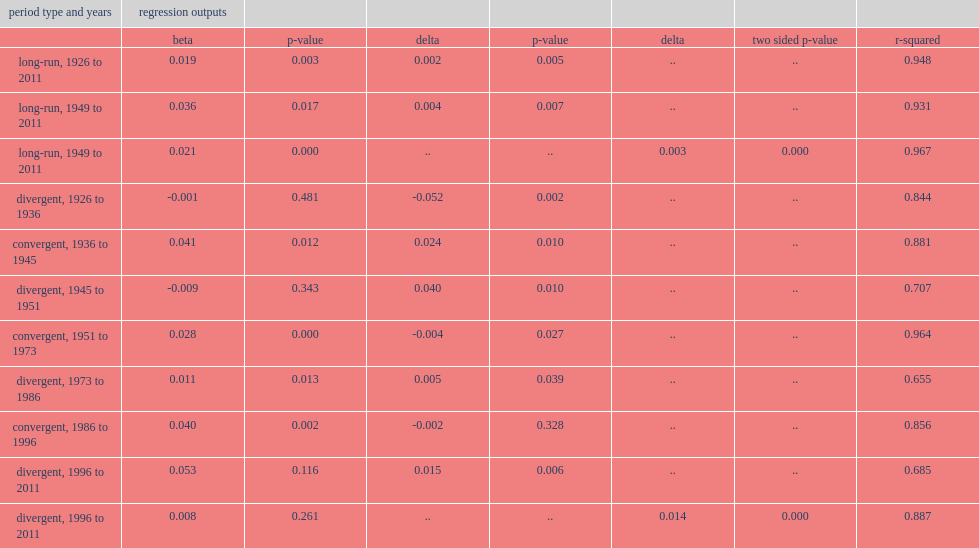For the three periods of convergence, the conditional convergence rate is slower than the unconditional rate, what was the percentage of convergent for 1936 to 1945? 0.041. For the three periods of convergence, the conditional convergence rate is slower than the unconditional rate, what was the percentage of convergent for 1951 to 1973? 0.028. For the three periods of convergence, the conditional convergence rate is slower than the unconditional rate, what was the percentage of convergent for 1951 to 1973? 0.04. 